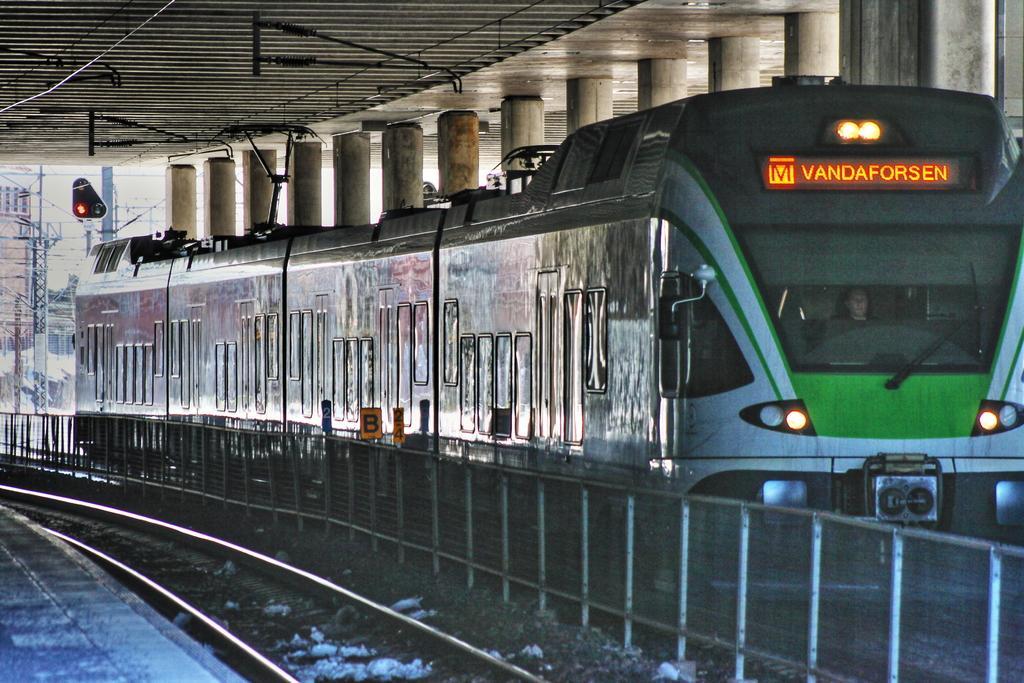Can you describe this image briefly? In this picture I can see a train on the railway track. There are poles, fence, cables, lights, pillars, boards, platform, and in the background there is the sky. 